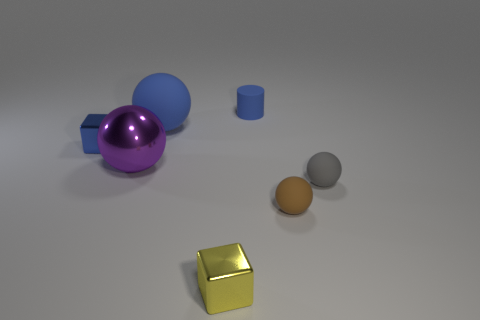Add 1 big blue spheres. How many objects exist? 8 Subtract all cylinders. How many objects are left? 6 Subtract all tiny cylinders. Subtract all small rubber objects. How many objects are left? 3 Add 4 blue blocks. How many blue blocks are left? 5 Add 4 tiny cyan shiny spheres. How many tiny cyan shiny spheres exist? 4 Subtract 0 cyan spheres. How many objects are left? 7 